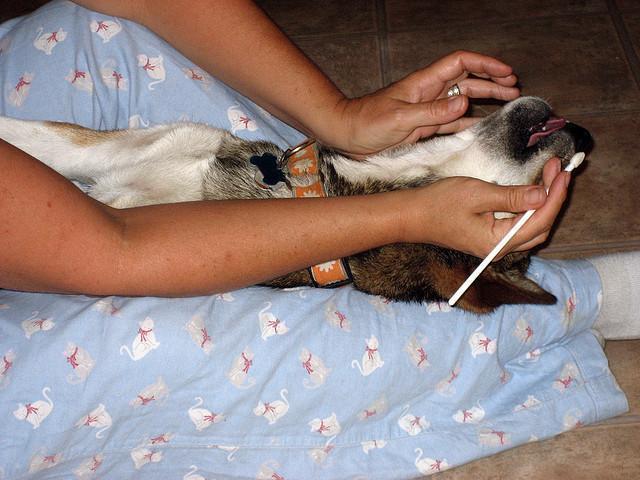How many people are visible?
Give a very brief answer. 1. 